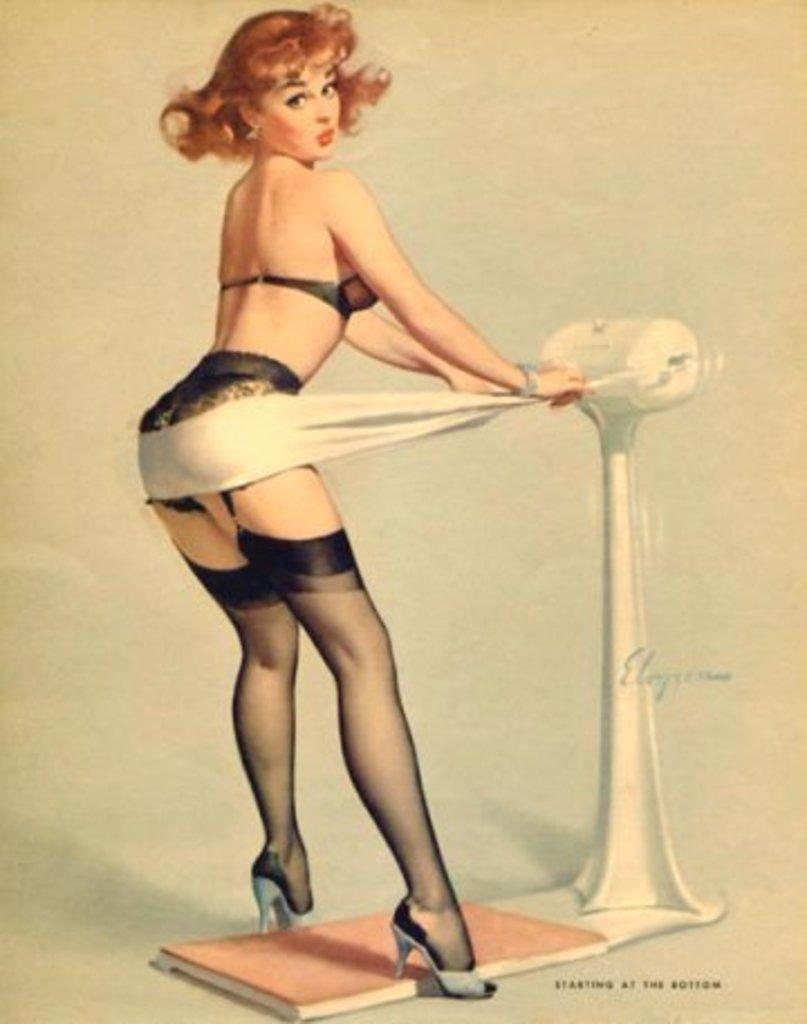Can you describe this image briefly? In this image there is one woman who is standing, and on the right side there is some object. At the bottom there is one board, and there is a white background. 